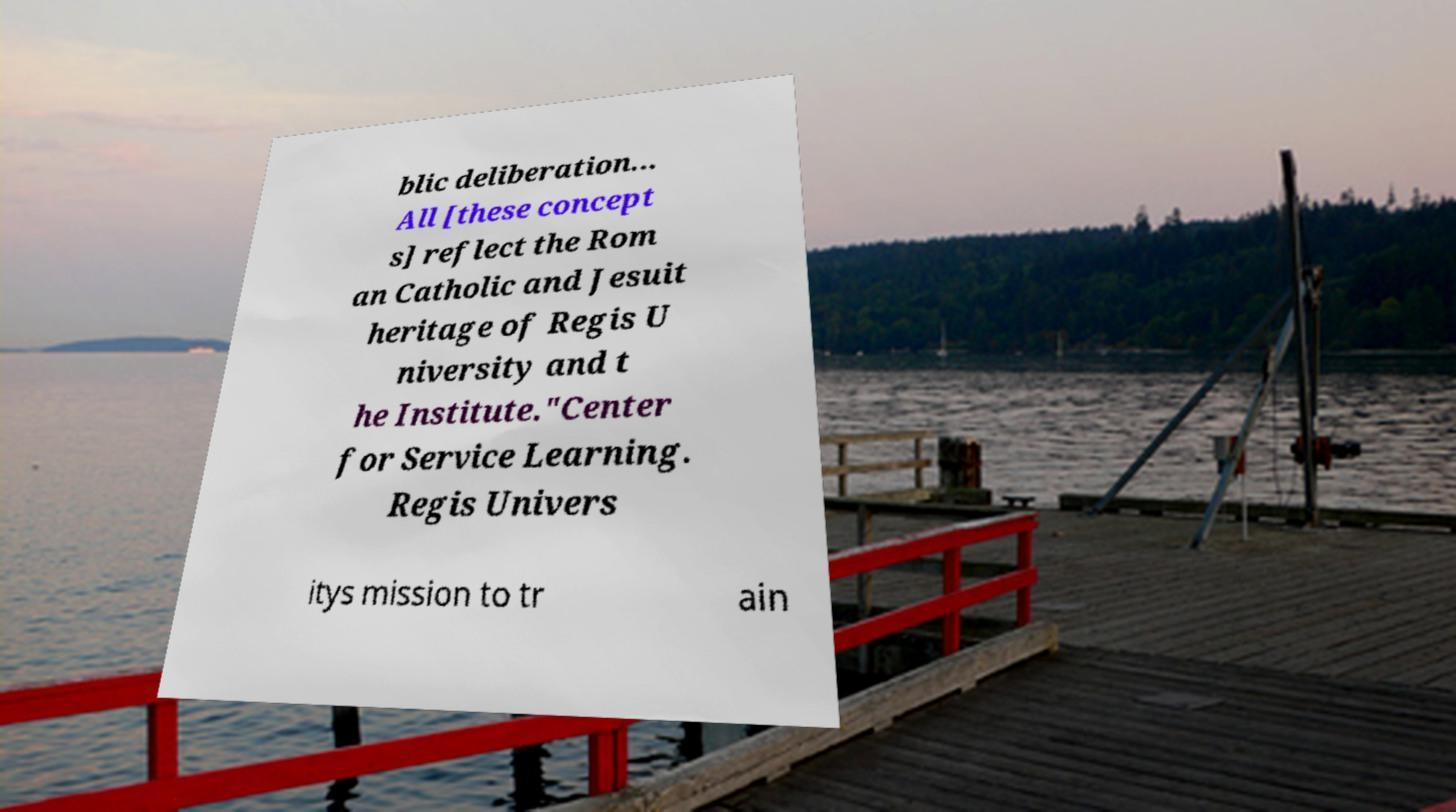Can you accurately transcribe the text from the provided image for me? blic deliberation... All [these concept s] reflect the Rom an Catholic and Jesuit heritage of Regis U niversity and t he Institute."Center for Service Learning. Regis Univers itys mission to tr ain 